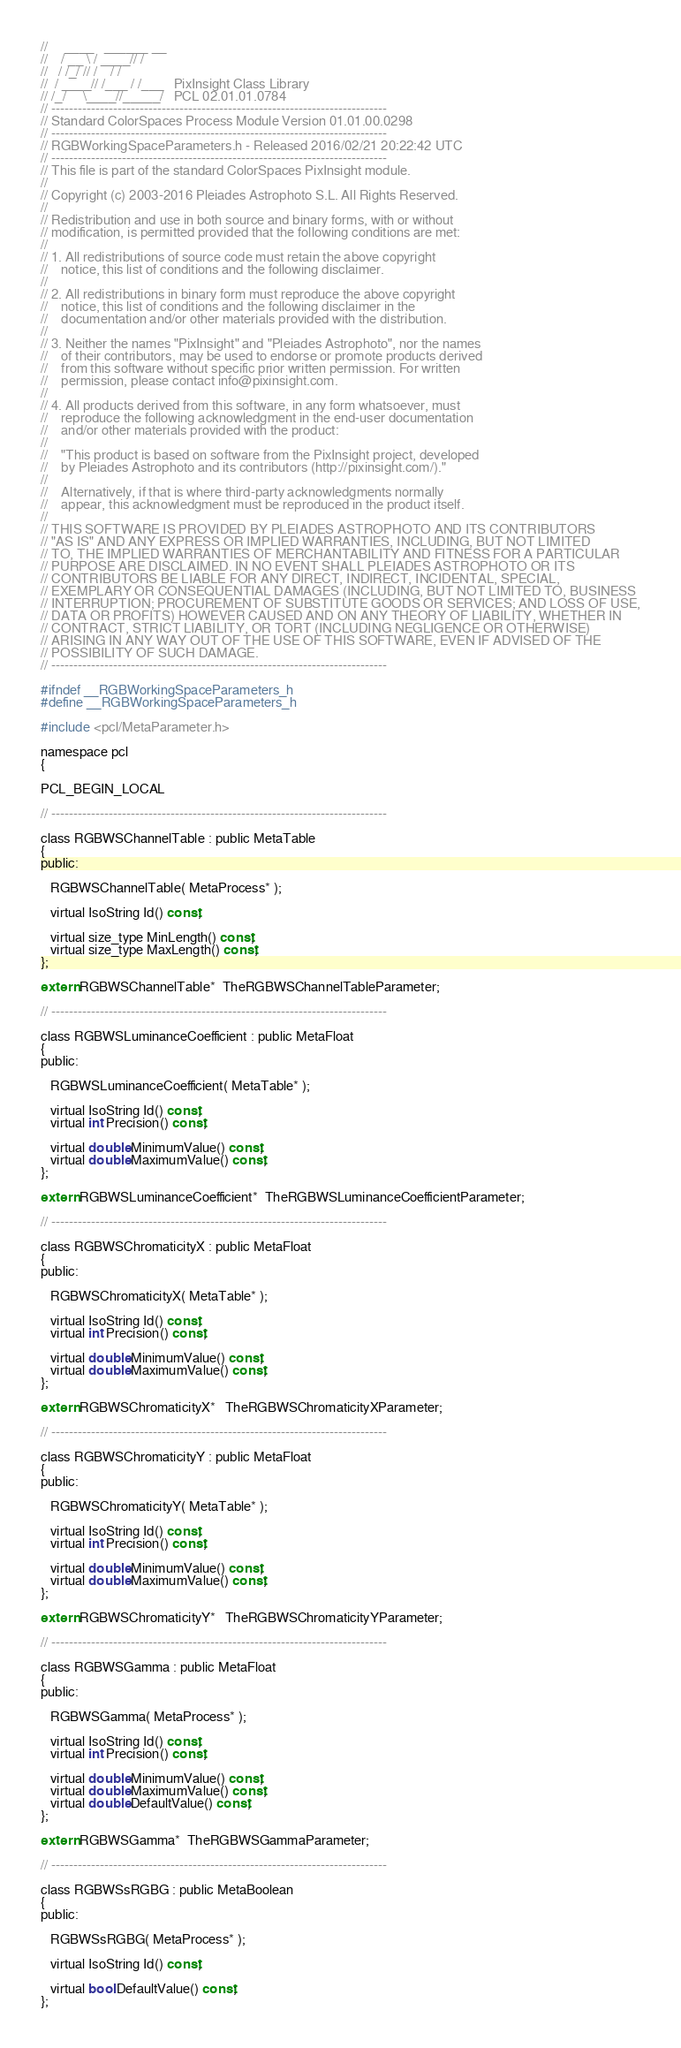<code> <loc_0><loc_0><loc_500><loc_500><_C_>//     ____   ______ __
//    / __ \ / ____// /
//   / /_/ // /    / /
//  / ____// /___ / /___   PixInsight Class Library
// /_/     \____//_____/   PCL 02.01.01.0784
// ----------------------------------------------------------------------------
// Standard ColorSpaces Process Module Version 01.01.00.0298
// ----------------------------------------------------------------------------
// RGBWorkingSpaceParameters.h - Released 2016/02/21 20:22:42 UTC
// ----------------------------------------------------------------------------
// This file is part of the standard ColorSpaces PixInsight module.
//
// Copyright (c) 2003-2016 Pleiades Astrophoto S.L. All Rights Reserved.
//
// Redistribution and use in both source and binary forms, with or without
// modification, is permitted provided that the following conditions are met:
//
// 1. All redistributions of source code must retain the above copyright
//    notice, this list of conditions and the following disclaimer.
//
// 2. All redistributions in binary form must reproduce the above copyright
//    notice, this list of conditions and the following disclaimer in the
//    documentation and/or other materials provided with the distribution.
//
// 3. Neither the names "PixInsight" and "Pleiades Astrophoto", nor the names
//    of their contributors, may be used to endorse or promote products derived
//    from this software without specific prior written permission. For written
//    permission, please contact info@pixinsight.com.
//
// 4. All products derived from this software, in any form whatsoever, must
//    reproduce the following acknowledgment in the end-user documentation
//    and/or other materials provided with the product:
//
//    "This product is based on software from the PixInsight project, developed
//    by Pleiades Astrophoto and its contributors (http://pixinsight.com/)."
//
//    Alternatively, if that is where third-party acknowledgments normally
//    appear, this acknowledgment must be reproduced in the product itself.
//
// THIS SOFTWARE IS PROVIDED BY PLEIADES ASTROPHOTO AND ITS CONTRIBUTORS
// "AS IS" AND ANY EXPRESS OR IMPLIED WARRANTIES, INCLUDING, BUT NOT LIMITED
// TO, THE IMPLIED WARRANTIES OF MERCHANTABILITY AND FITNESS FOR A PARTICULAR
// PURPOSE ARE DISCLAIMED. IN NO EVENT SHALL PLEIADES ASTROPHOTO OR ITS
// CONTRIBUTORS BE LIABLE FOR ANY DIRECT, INDIRECT, INCIDENTAL, SPECIAL,
// EXEMPLARY OR CONSEQUENTIAL DAMAGES (INCLUDING, BUT NOT LIMITED TO, BUSINESS
// INTERRUPTION; PROCUREMENT OF SUBSTITUTE GOODS OR SERVICES; AND LOSS OF USE,
// DATA OR PROFITS) HOWEVER CAUSED AND ON ANY THEORY OF LIABILITY, WHETHER IN
// CONTRACT, STRICT LIABILITY, OR TORT (INCLUDING NEGLIGENCE OR OTHERWISE)
// ARISING IN ANY WAY OUT OF THE USE OF THIS SOFTWARE, EVEN IF ADVISED OF THE
// POSSIBILITY OF SUCH DAMAGE.
// ----------------------------------------------------------------------------

#ifndef __RGBWorkingSpaceParameters_h
#define __RGBWorkingSpaceParameters_h

#include <pcl/MetaParameter.h>

namespace pcl
{

PCL_BEGIN_LOCAL

// ----------------------------------------------------------------------------

class RGBWSChannelTable : public MetaTable
{
public:

   RGBWSChannelTable( MetaProcess* );

   virtual IsoString Id() const;

   virtual size_type MinLength() const;
   virtual size_type MaxLength() const;
};

extern RGBWSChannelTable*  TheRGBWSChannelTableParameter;

// ----------------------------------------------------------------------------

class RGBWSLuminanceCoefficient : public MetaFloat
{
public:

   RGBWSLuminanceCoefficient( MetaTable* );

   virtual IsoString Id() const;
   virtual int Precision() const;

   virtual double MinimumValue() const;
   virtual double MaximumValue() const;
};

extern RGBWSLuminanceCoefficient*  TheRGBWSLuminanceCoefficientParameter;

// ----------------------------------------------------------------------------

class RGBWSChromaticityX : public MetaFloat
{
public:

   RGBWSChromaticityX( MetaTable* );

   virtual IsoString Id() const;
   virtual int Precision() const;

   virtual double MinimumValue() const;
   virtual double MaximumValue() const;
};

extern RGBWSChromaticityX*   TheRGBWSChromaticityXParameter;

// ----------------------------------------------------------------------------

class RGBWSChromaticityY : public MetaFloat
{
public:

   RGBWSChromaticityY( MetaTable* );

   virtual IsoString Id() const;
   virtual int Precision() const;

   virtual double MinimumValue() const;
   virtual double MaximumValue() const;
};

extern RGBWSChromaticityY*   TheRGBWSChromaticityYParameter;

// ----------------------------------------------------------------------------

class RGBWSGamma : public MetaFloat
{
public:

   RGBWSGamma( MetaProcess* );

   virtual IsoString Id() const;
   virtual int Precision() const;

   virtual double MinimumValue() const;
   virtual double MaximumValue() const;
   virtual double DefaultValue() const;
};

extern RGBWSGamma*  TheRGBWSGammaParameter;

// ----------------------------------------------------------------------------

class RGBWSsRGBG : public MetaBoolean
{
public:

   RGBWSsRGBG( MetaProcess* );

   virtual IsoString Id() const;

   virtual bool DefaultValue() const;
};
</code> 